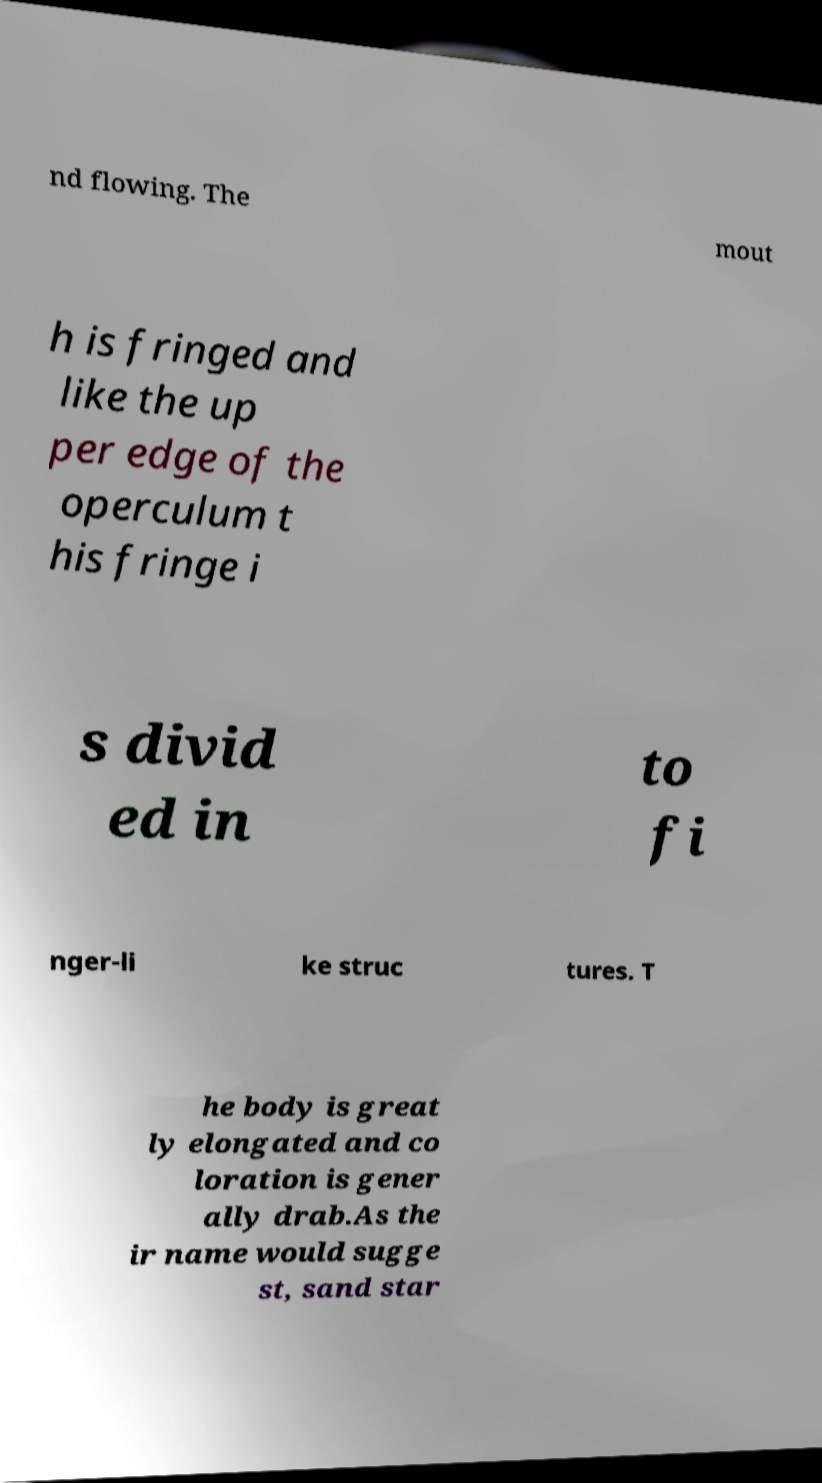For documentation purposes, I need the text within this image transcribed. Could you provide that? nd flowing. The mout h is fringed and like the up per edge of the operculum t his fringe i s divid ed in to fi nger-li ke struc tures. T he body is great ly elongated and co loration is gener ally drab.As the ir name would sugge st, sand star 